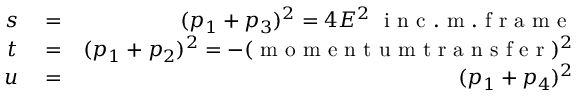Convert formula to latex. <formula><loc_0><loc_0><loc_500><loc_500>\begin{array} { r l r } { s } & = } & { ( p _ { 1 } + p _ { 3 } ) ^ { 2 } = 4 E ^ { 2 } \ i n c . m . f r a m e } \\ { t } & = } & { ( p _ { 1 } + p _ { 2 } ) ^ { 2 } = - ( m o m e n t u m t r a n s f e r ) ^ { 2 } } \\ { u } & = } & { ( p _ { 1 } + p _ { 4 } ) ^ { 2 } } \end{array}</formula> 